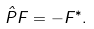Convert formula to latex. <formula><loc_0><loc_0><loc_500><loc_500>\hat { P } { F } = - { F } ^ { * } .</formula> 